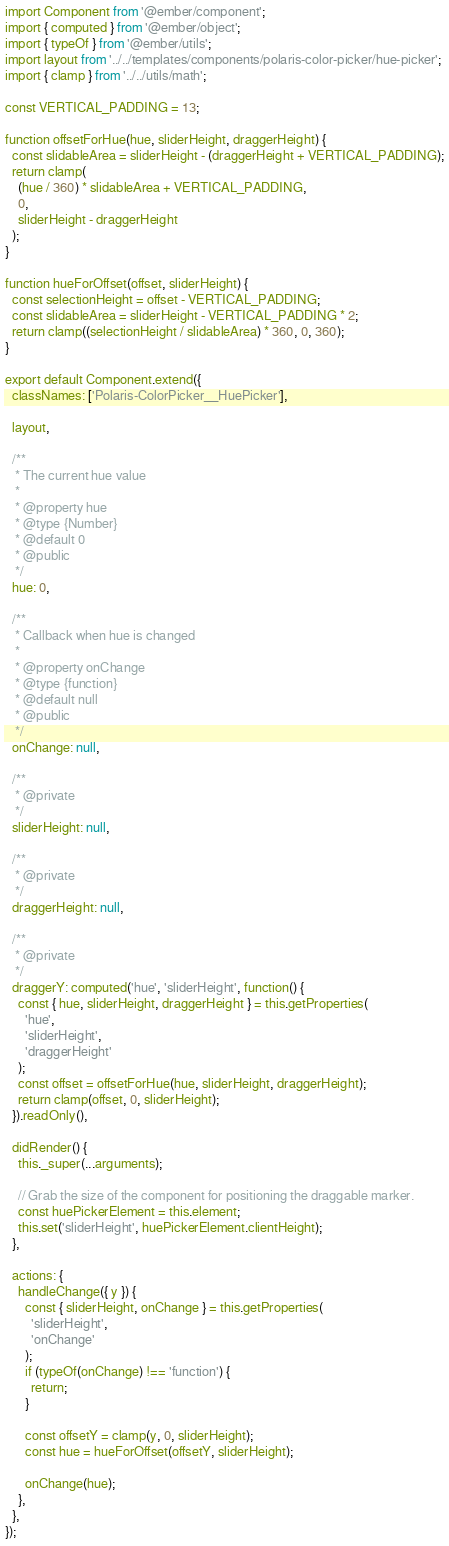Convert code to text. <code><loc_0><loc_0><loc_500><loc_500><_JavaScript_>import Component from '@ember/component';
import { computed } from '@ember/object';
import { typeOf } from '@ember/utils';
import layout from '../../templates/components/polaris-color-picker/hue-picker';
import { clamp } from '../../utils/math';

const VERTICAL_PADDING = 13;

function offsetForHue(hue, sliderHeight, draggerHeight) {
  const slidableArea = sliderHeight - (draggerHeight + VERTICAL_PADDING);
  return clamp(
    (hue / 360) * slidableArea + VERTICAL_PADDING,
    0,
    sliderHeight - draggerHeight
  );
}

function hueForOffset(offset, sliderHeight) {
  const selectionHeight = offset - VERTICAL_PADDING;
  const slidableArea = sliderHeight - VERTICAL_PADDING * 2;
  return clamp((selectionHeight / slidableArea) * 360, 0, 360);
}

export default Component.extend({
  classNames: ['Polaris-ColorPicker__HuePicker'],

  layout,

  /**
   * The current hue value
   *
   * @property hue
   * @type {Number}
   * @default 0
   * @public
   */
  hue: 0,

  /**
   * Callback when hue is changed
   *
   * @property onChange
   * @type {function}
   * @default null
   * @public
   */
  onChange: null,

  /**
   * @private
   */
  sliderHeight: null,

  /**
   * @private
   */
  draggerHeight: null,

  /**
   * @private
   */
  draggerY: computed('hue', 'sliderHeight', function() {
    const { hue, sliderHeight, draggerHeight } = this.getProperties(
      'hue',
      'sliderHeight',
      'draggerHeight'
    );
    const offset = offsetForHue(hue, sliderHeight, draggerHeight);
    return clamp(offset, 0, sliderHeight);
  }).readOnly(),

  didRender() {
    this._super(...arguments);

    // Grab the size of the component for positioning the draggable marker.
    const huePickerElement = this.element;
    this.set('sliderHeight', huePickerElement.clientHeight);
  },

  actions: {
    handleChange({ y }) {
      const { sliderHeight, onChange } = this.getProperties(
        'sliderHeight',
        'onChange'
      );
      if (typeOf(onChange) !== 'function') {
        return;
      }

      const offsetY = clamp(y, 0, sliderHeight);
      const hue = hueForOffset(offsetY, sliderHeight);

      onChange(hue);
    },
  },
});
</code> 